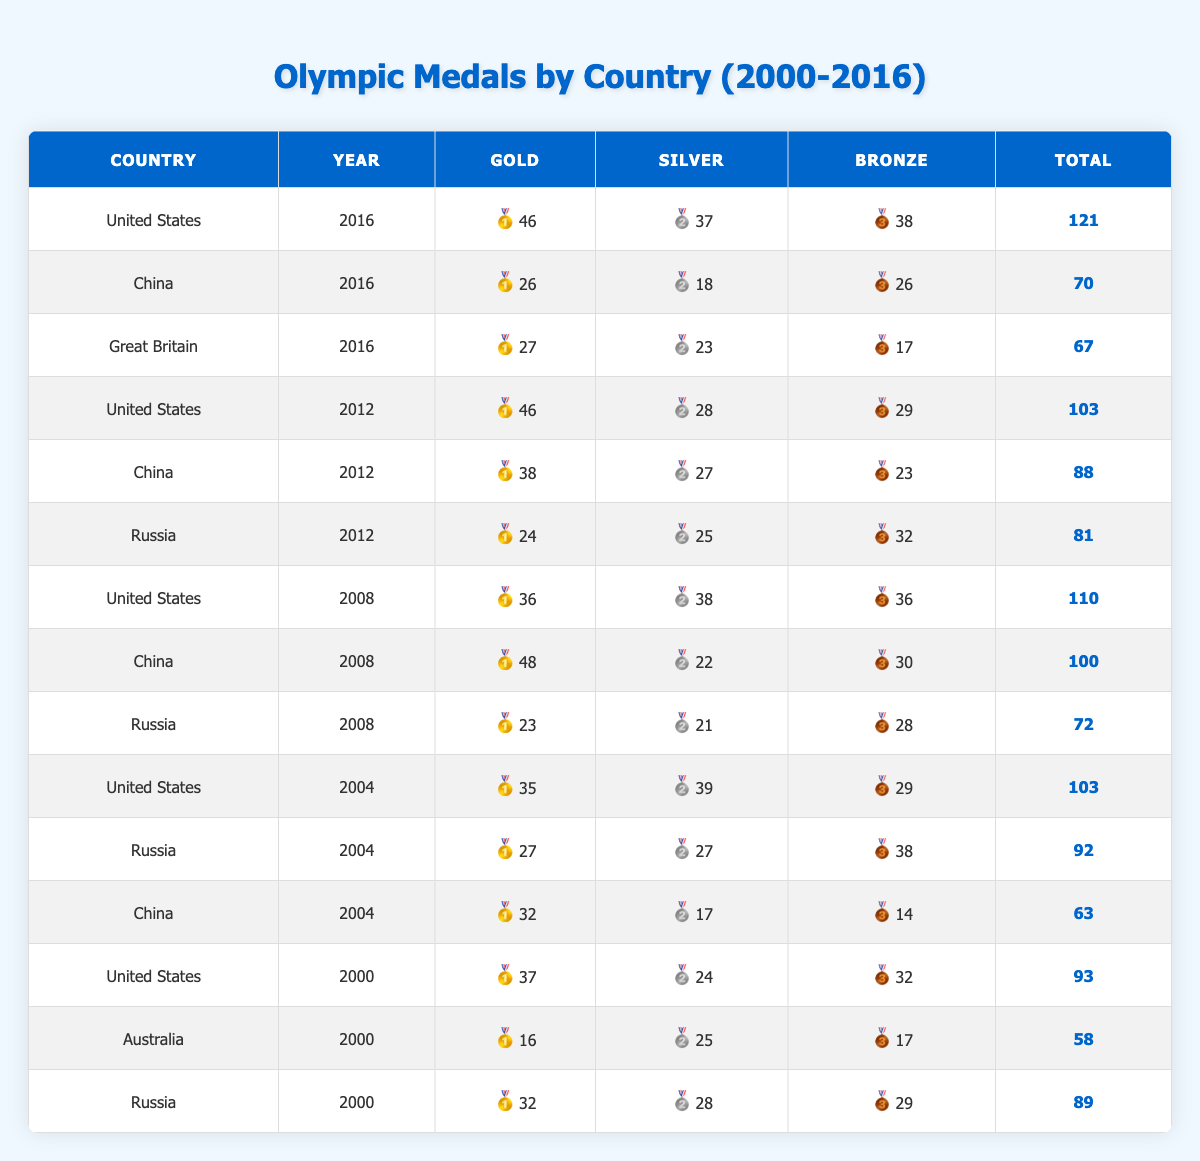What country won the most gold medals in 2016? In the table, the United States has the highest count of gold medals in 2016 with 46.
Answer: United States How many total medals did China win in the 2008 Olympics? For the year 2008, China won a total of 100 medals (48 gold, 22 silver, and 30 bronze), which sums up to 100.
Answer: 100 Which country had more total medals in 2012: China or Russia? In 2012, China had 88 total medals and Russia had 81 total medals; therefore, China had more total medals.
Answer: China What is the total number of gold medals won by the United States from 2000 to 2016? The gold medals for the United States are 37 (2000) + 35 (2004) + 36 (2008) + 46 (2012) + 46 (2016), which totals 200.
Answer: 200 Did Great Britain win more silver or bronze medals in 2016? In 2016, Great Britain won 23 silver and 17 bronze medals, showing that they won more silver medals.
Answer: Yes Who had the highest total medal count in the Olympics from 2000 to 2016? The United States consistently had the highest total counts: 93 (2000), 103 (2004), 110 (2008), 46 (2012), 121 (2016). Adding those gives a total of 121 medals in 2016.
Answer: United States How many more gold medals did the United States win than Russia in 2004? In 2004, the United States won 35 gold medals and Russia won 27 gold medals; the difference is 35 - 27 = 8.
Answer: 8 What year did Russia have the highest total medal count? By checking the table, in 2008, Russia had 72 total medals which is higher than their totals in 2004 or 2012.
Answer: 2008 What is the average number of bronze medals won by Australia in the years provided? Australia appears only once in 2000 with 17 bronze medals, therefore the average is simply 17/1 = 17.
Answer: 17 Was the total medal count for China in 2004 less than that in 2012? In 2004, China had a total of 63 medals and in 2012, they had 88; thus, yes, 63 is less than 88.
Answer: Yes 